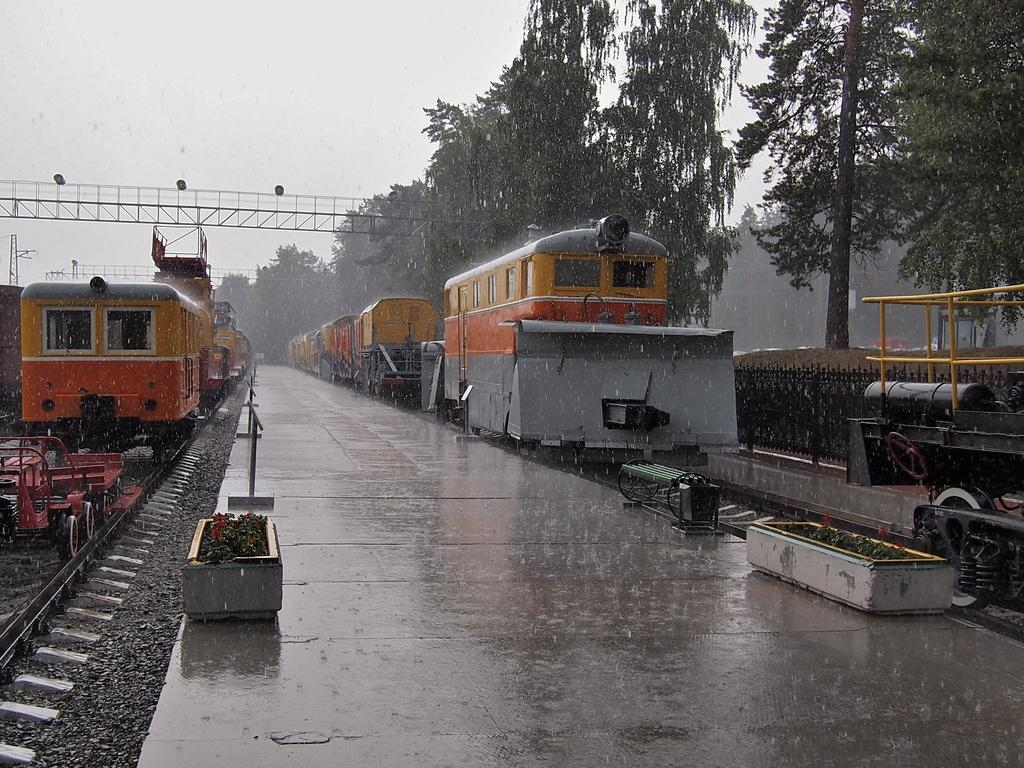What type of vehicles are present on the railway tracks in the image? There are trains on the railway tracks in the image. What is located beside the railway tracks? There is a platform beside the railway tracks. What can be seen near the platform? There are objects visible near the platform. What is visible in the background of the image? There are trees and the sky visible in the background of the image. Can you see a boat floating on the water near the platform in the image? There is no boat or water visible in the image; it features trains on railway tracks with a platform and trees in the background. 